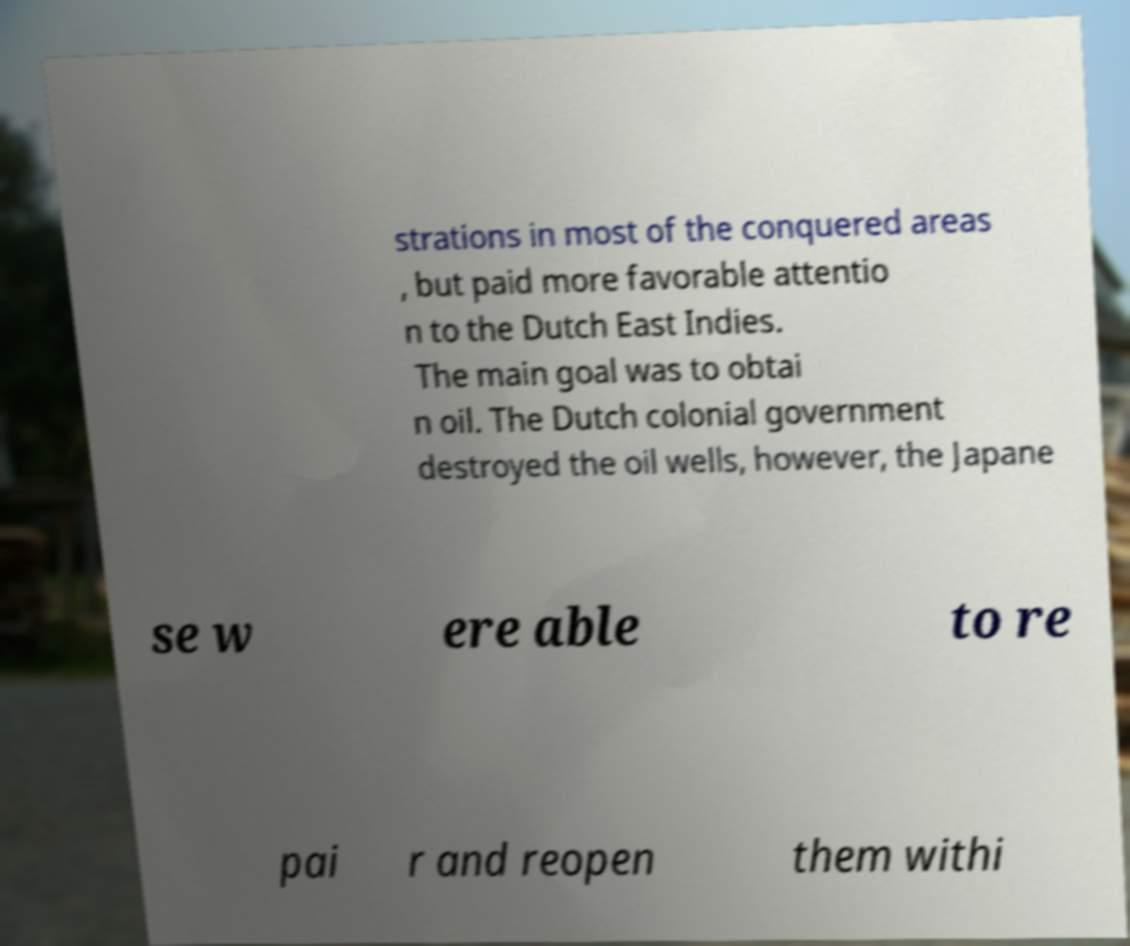Please read and relay the text visible in this image. What does it say? strations in most of the conquered areas , but paid more favorable attentio n to the Dutch East Indies. The main goal was to obtai n oil. The Dutch colonial government destroyed the oil wells, however, the Japane se w ere able to re pai r and reopen them withi 